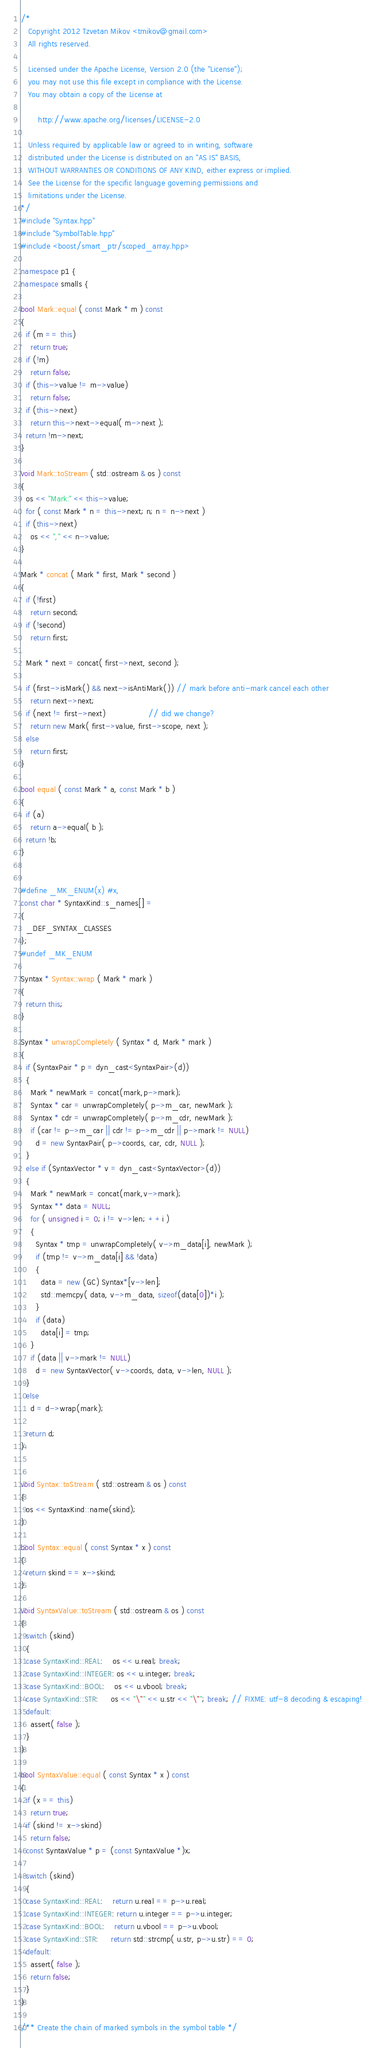Convert code to text. <code><loc_0><loc_0><loc_500><loc_500><_C++_>/*
   Copyright 2012 Tzvetan Mikov <tmikov@gmail.com>
   All rights reserved.

   Licensed under the Apache License, Version 2.0 (the "License");
   you may not use this file except in compliance with the License.
   You may obtain a copy of the License at

       http://www.apache.org/licenses/LICENSE-2.0

   Unless required by applicable law or agreed to in writing, software
   distributed under the License is distributed on an "AS IS" BASIS,
   WITHOUT WARRANTIES OR CONDITIONS OF ANY KIND, either express or implied.
   See the License for the specific language governing permissions and
   limitations under the License.
*/
#include "Syntax.hpp"
#include "SymbolTable.hpp"
#include <boost/smart_ptr/scoped_array.hpp>

namespace p1 {
namespace smalls {

bool Mark::equal ( const Mark * m ) const
{
  if (m == this)
    return true;
  if (!m)
    return false;
  if (this->value != m->value)
    return false;
  if (this->next)
    return this->next->equal( m->next );
  return !m->next;
}

void Mark::toStream ( std::ostream & os ) const
{
  os << "Mark:" << this->value;
  for ( const Mark * n = this->next; n; n = n->next )
  if (this->next)
    os << "," << n->value;
}

Mark * concat ( Mark * first, Mark * second )
{
  if (!first)
    return second;
  if (!second)
    return first;

  Mark * next = concat( first->next, second );

  if (first->isMark() && next->isAntiMark()) // mark before anti-mark cancel each other
    return next->next;
  if (next != first->next)                 // did we change?
    return new Mark( first->value, first->scope, next );
  else
    return first;
}

bool equal ( const Mark * a, const Mark * b )
{
  if (a)
    return a->equal( b );
  return !b;
}


#define _MK_ENUM(x) #x,
const char * SyntaxKind::s_names[] =
{
  _DEF_SYNTAX_CLASSES
};
#undef _MK_ENUM

Syntax * Syntax::wrap ( Mark * mark )
{
  return this;
}

Syntax * unwrapCompletely ( Syntax * d, Mark * mark )
{
  if (SyntaxPair * p = dyn_cast<SyntaxPair>(d))
  {
    Mark * newMark = concat(mark,p->mark);
    Syntax * car = unwrapCompletely( p->m_car, newMark );
    Syntax * cdr = unwrapCompletely( p->m_cdr, newMark );
    if (car != p->m_car || cdr != p->m_cdr || p->mark != NULL)
      d = new SyntaxPair( p->coords, car, cdr, NULL );
  }
  else if (SyntaxVector * v = dyn_cast<SyntaxVector>(d))
  {
    Mark * newMark = concat(mark,v->mark);
    Syntax ** data = NULL;
    for ( unsigned i = 0; i != v->len; ++i )
    {
      Syntax * tmp = unwrapCompletely( v->m_data[i], newMark );
      if (tmp != v->m_data[i] && !data)
      {
        data = new (GC) Syntax*[v->len];
        std::memcpy( data, v->m_data, sizeof(data[0])*i );
      }
      if (data)
        data[i] = tmp;
    }
    if (data || v->mark != NULL)
      d = new SyntaxVector( v->coords, data, v->len, NULL );
  }
  else
    d = d->wrap(mark);

  return d;
}


void Syntax::toStream ( std::ostream & os ) const
{
  os << SyntaxKind::name(skind);
}

bool Syntax::equal ( const Syntax * x ) const
{
  return skind == x->skind;
}

void SyntaxValue::toStream ( std::ostream & os ) const
{
  switch (skind)
  {
  case SyntaxKind::REAL:    os << u.real; break;
  case SyntaxKind::INTEGER: os << u.integer; break;
  case SyntaxKind::BOOL:    os << u.vbool; break;
  case SyntaxKind::STR:     os << "\"" << u.str << "\""; break; // FIXME: utf-8 decoding & escaping!
  default:
    assert( false );
  }
}

bool SyntaxValue::equal ( const Syntax * x ) const
{
  if (x == this)
    return true;
  if (skind != x->skind)
    return false;
  const SyntaxValue * p = (const SyntaxValue *)x;

  switch (skind)
  {
  case SyntaxKind::REAL:    return u.real == p->u.real;
  case SyntaxKind::INTEGER: return u.integer == p->u.integer;
  case SyntaxKind::BOOL:    return u.vbool == p->u.vbool;
  case SyntaxKind::STR:     return std::strcmp( u.str, p->u.str) == 0;
  default:
    assert( false );
    return false;
  }
}

/** Create the chain of marked symbols in the symbol table */</code> 